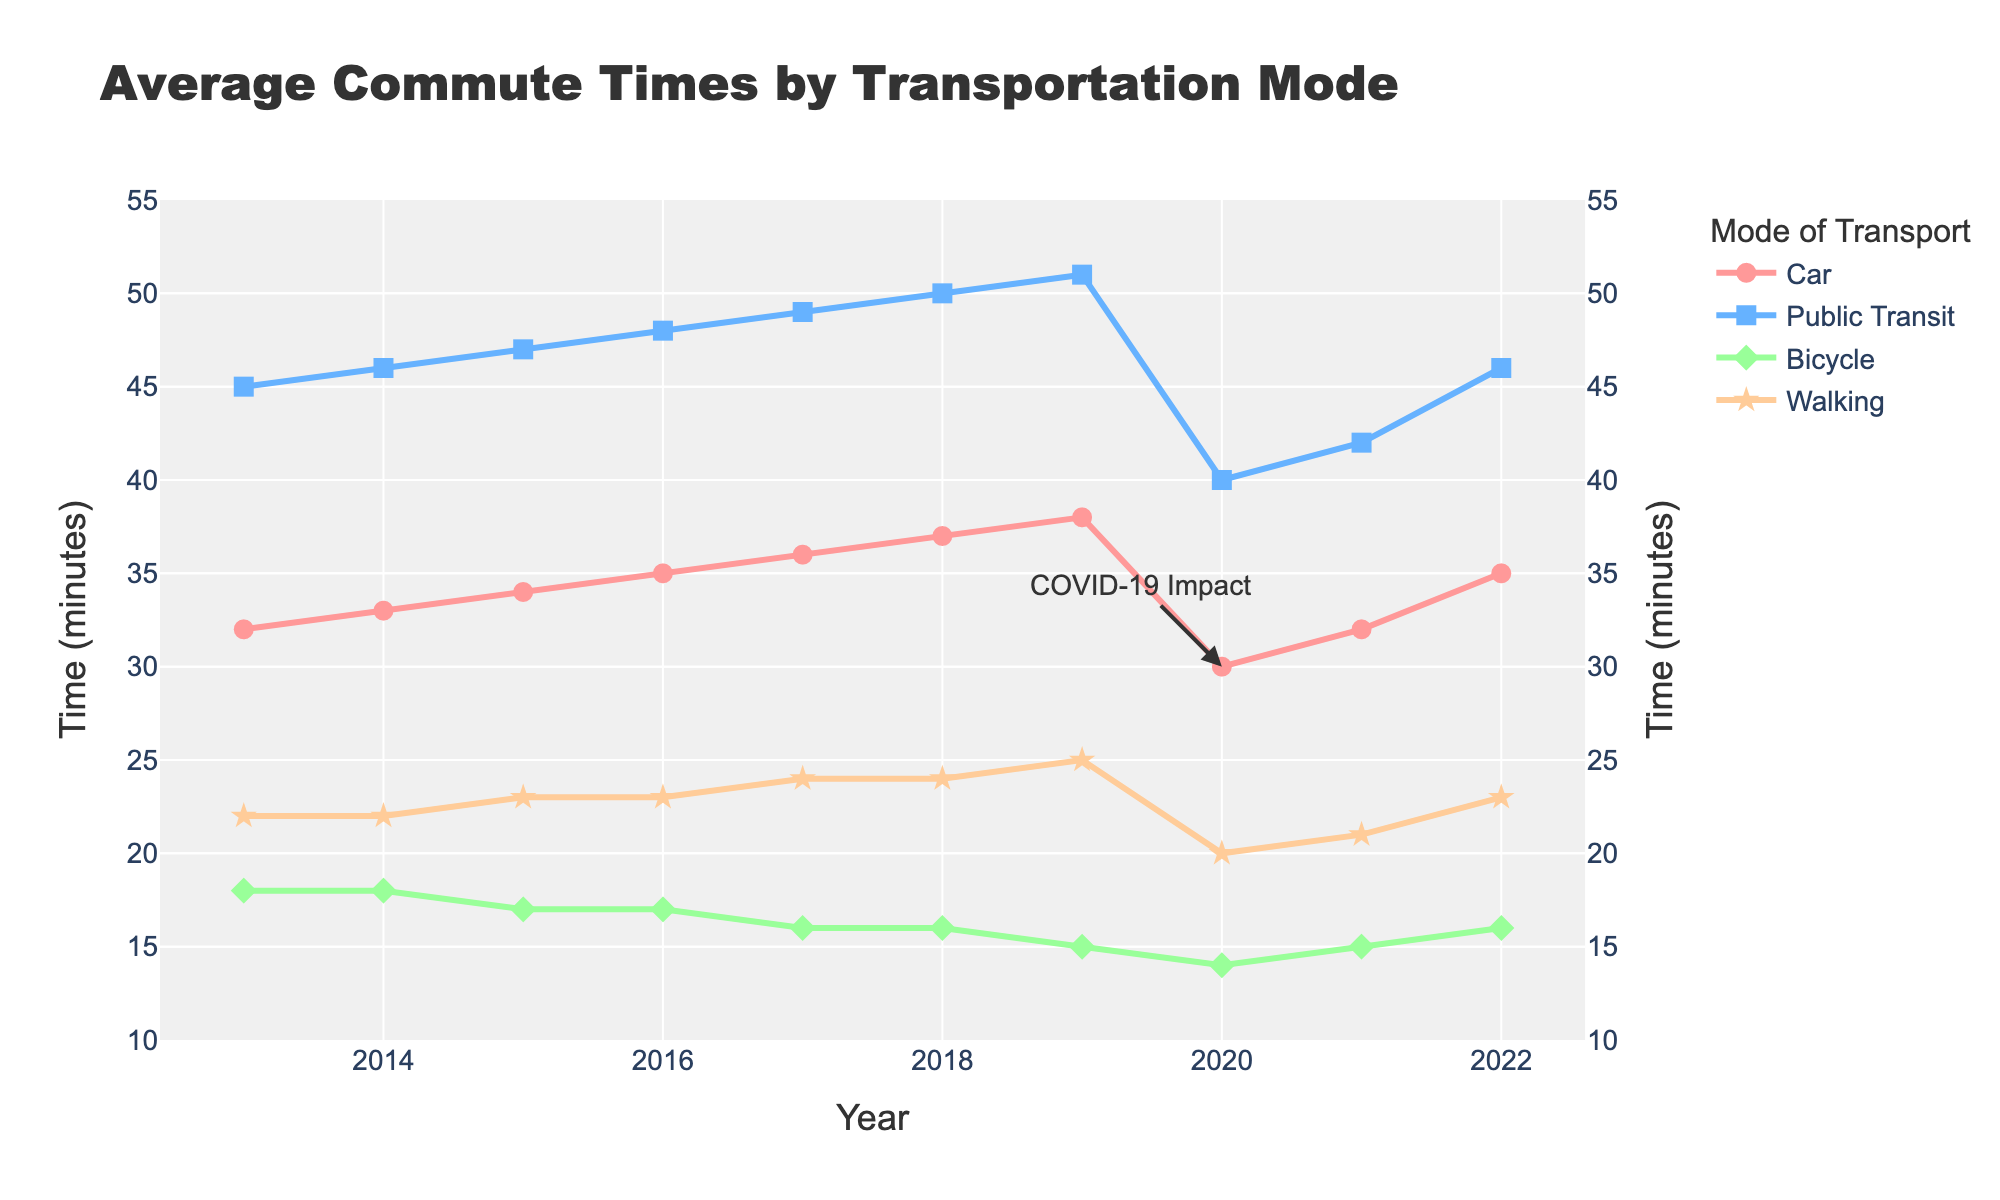What is the average commute time for cars in 2019? The commute time for cars in 2019 is shown on the chart as a line labeled "Car." We can see that the value for 2019 is 38 minutes.
Answer: 38 minutes Which mode of transportation had the largest decrease in average commute time in 2020 compared to 2019? By examining the slopes of the lines between 2019 and 2020, we see that all modes of transport experienced a decrease, but the steepest is for Public Transit, which dropped from 51 minutes to 40 minutes.
Answer: Public Transit What was the commute time for walking in the year 2015? We look at the line labeled "Walking" and find the corresponding point for the year 2015. The value is 23 minutes.
Answer: 23 minutes Between which years did the bicycle commute time decrease the most? We observe the green line (Bicycle) and notice points where the slope is steepest. The most significant decrease occurs between 2019 and 2020, from 15 to 14 minutes.
Answer: 2019-2020 How did the public transit commute time in 2021 compare to that in 2017? Looking at the blue line (Public Transit), in 2017 it's at 49 minutes, while in 2021 it's at 42 minutes. Public transit commute time in 2021 is 7 minutes shorter than in 2017.
Answer: 7 minutes shorter What was the percentage change in average commute time for cars from 2014 to 2018? The commute time for cars in 2014 was 33 minutes and 37 minutes in 2018. The percentage change is calculated as ((37 - 33) / 33) * 100.
Answer: 12.12% In what year did walking have its highest commute time, and what was the value? We look at the star-marked line (Walking) for the highest point. It maxes out in 2019 and 2022 at 25 minutes.
Answer: 2019 and 2022, 25 minutes Compare the change in commute times for cars and public transit from 2016 to 2019. The car commute time increased from 35 to 38 minutes, a change of 3 minutes. Public transit went from 48 to 51 minutes, a change of 3 minutes. Both increased by 3 minutes.
Answer: Both increased by 3 minutes What trend can be observed in the bicycle commute times from 2013 to 2022? The green line shows a general downward trend from 18 minutes in 2013 to 16 minutes in 2022, with a slight decrease over the decade.
Answer: Downward trend 